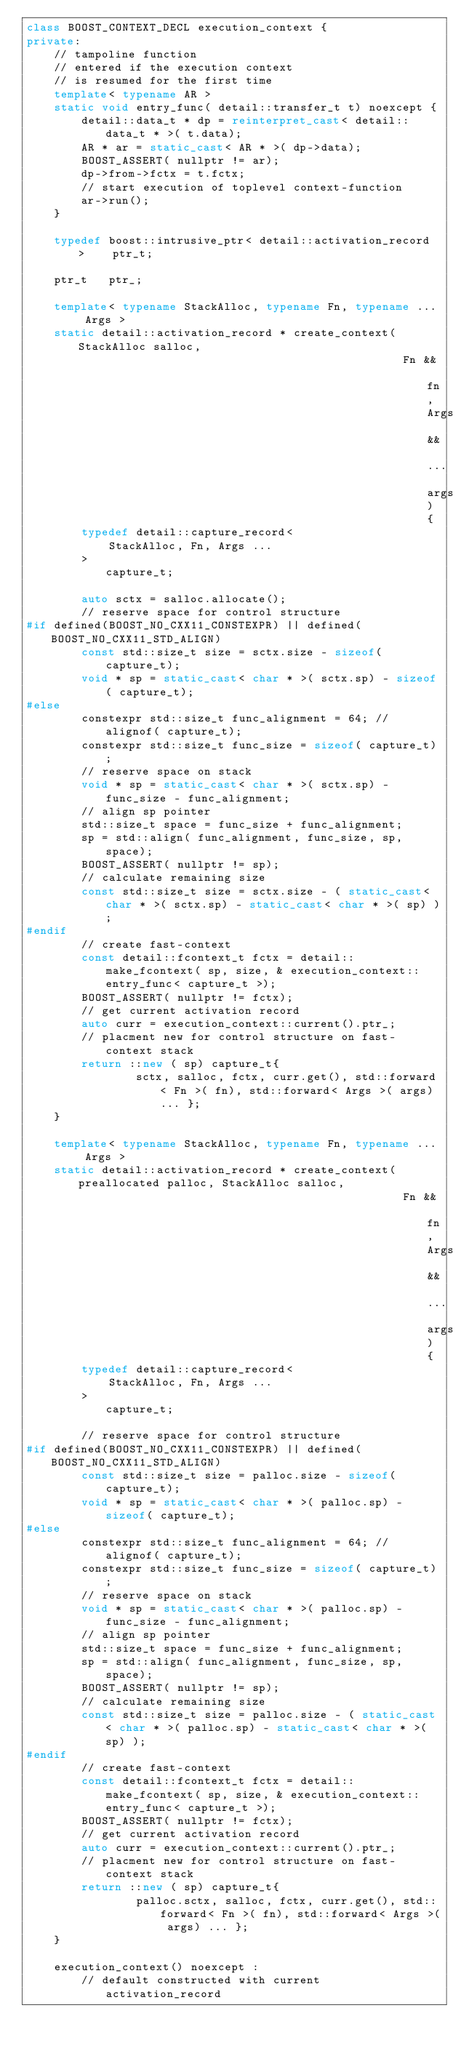<code> <loc_0><loc_0><loc_500><loc_500><_C++_>class BOOST_CONTEXT_DECL execution_context {
private:
    // tampoline function
    // entered if the execution context
    // is resumed for the first time
    template< typename AR >
    static void entry_func( detail::transfer_t t) noexcept {
        detail::data_t * dp = reinterpret_cast< detail::data_t * >( t.data);
        AR * ar = static_cast< AR * >( dp->data);
        BOOST_ASSERT( nullptr != ar);
        dp->from->fctx = t.fctx;
        // start execution of toplevel context-function
        ar->run();
    }

    typedef boost::intrusive_ptr< detail::activation_record >    ptr_t;

    ptr_t   ptr_;

    template< typename StackAlloc, typename Fn, typename ... Args >
    static detail::activation_record * create_context( StackAlloc salloc,
                                                       Fn && fn, Args && ... args) {
        typedef detail::capture_record<
            StackAlloc, Fn, Args ...
        >                                           capture_t;

        auto sctx = salloc.allocate();
        // reserve space for control structure
#if defined(BOOST_NO_CXX11_CONSTEXPR) || defined(BOOST_NO_CXX11_STD_ALIGN)
        const std::size_t size = sctx.size - sizeof( capture_t);
        void * sp = static_cast< char * >( sctx.sp) - sizeof( capture_t);
#else
        constexpr std::size_t func_alignment = 64; // alignof( capture_t);
        constexpr std::size_t func_size = sizeof( capture_t);
        // reserve space on stack
        void * sp = static_cast< char * >( sctx.sp) - func_size - func_alignment;
        // align sp pointer
        std::size_t space = func_size + func_alignment;
        sp = std::align( func_alignment, func_size, sp, space);
        BOOST_ASSERT( nullptr != sp);
        // calculate remaining size
        const std::size_t size = sctx.size - ( static_cast< char * >( sctx.sp) - static_cast< char * >( sp) );
#endif
        // create fast-context
        const detail::fcontext_t fctx = detail::make_fcontext( sp, size, & execution_context::entry_func< capture_t >);
        BOOST_ASSERT( nullptr != fctx);
        // get current activation record
        auto curr = execution_context::current().ptr_;
        // placment new for control structure on fast-context stack
        return ::new ( sp) capture_t{
                sctx, salloc, fctx, curr.get(), std::forward< Fn >( fn), std::forward< Args >( args) ... };
    }

    template< typename StackAlloc, typename Fn, typename ... Args >
    static detail::activation_record * create_context( preallocated palloc, StackAlloc salloc,
                                                       Fn && fn, Args && ... args) {
        typedef detail::capture_record<
            StackAlloc, Fn, Args ...
        >                                           capture_t;

        // reserve space for control structure
#if defined(BOOST_NO_CXX11_CONSTEXPR) || defined(BOOST_NO_CXX11_STD_ALIGN)
        const std::size_t size = palloc.size - sizeof( capture_t);
        void * sp = static_cast< char * >( palloc.sp) - sizeof( capture_t);
#else
        constexpr std::size_t func_alignment = 64; // alignof( capture_t);
        constexpr std::size_t func_size = sizeof( capture_t);
        // reserve space on stack
        void * sp = static_cast< char * >( palloc.sp) - func_size - func_alignment;
        // align sp pointer
        std::size_t space = func_size + func_alignment;
        sp = std::align( func_alignment, func_size, sp, space);
        BOOST_ASSERT( nullptr != sp);
        // calculate remaining size
        const std::size_t size = palloc.size - ( static_cast< char * >( palloc.sp) - static_cast< char * >( sp) );
#endif
        // create fast-context
        const detail::fcontext_t fctx = detail::make_fcontext( sp, size, & execution_context::entry_func< capture_t >);
        BOOST_ASSERT( nullptr != fctx);
        // get current activation record
        auto curr = execution_context::current().ptr_;
        // placment new for control structure on fast-context stack
        return ::new ( sp) capture_t{
                palloc.sctx, salloc, fctx, curr.get(), std::forward< Fn >( fn), std::forward< Args >( args) ... };
    }

    execution_context() noexcept :
        // default constructed with current activation_record</code> 